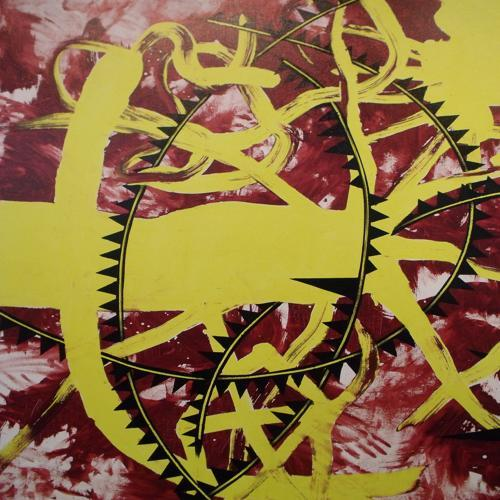Can you tell me more about the color palette used here? The artist has chosen a palette dominated by warm, deep reds and bright, electric yellows. These colors create a striking contrast and may symbolize opposing forces or energies in play. What do you think is the focal point of this artwork? The artwork's focal point appears to be the central yellow form, which is the brightest and most distinct shape, drawing the eye amidst the surrounding chaos of reds and dark tones. 